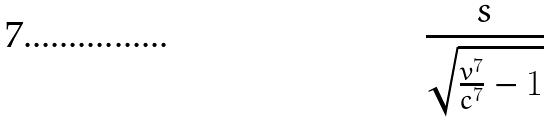<formula> <loc_0><loc_0><loc_500><loc_500>\frac { s } { \sqrt { \frac { v ^ { 7 } } { c ^ { 7 } } - 1 } }</formula> 